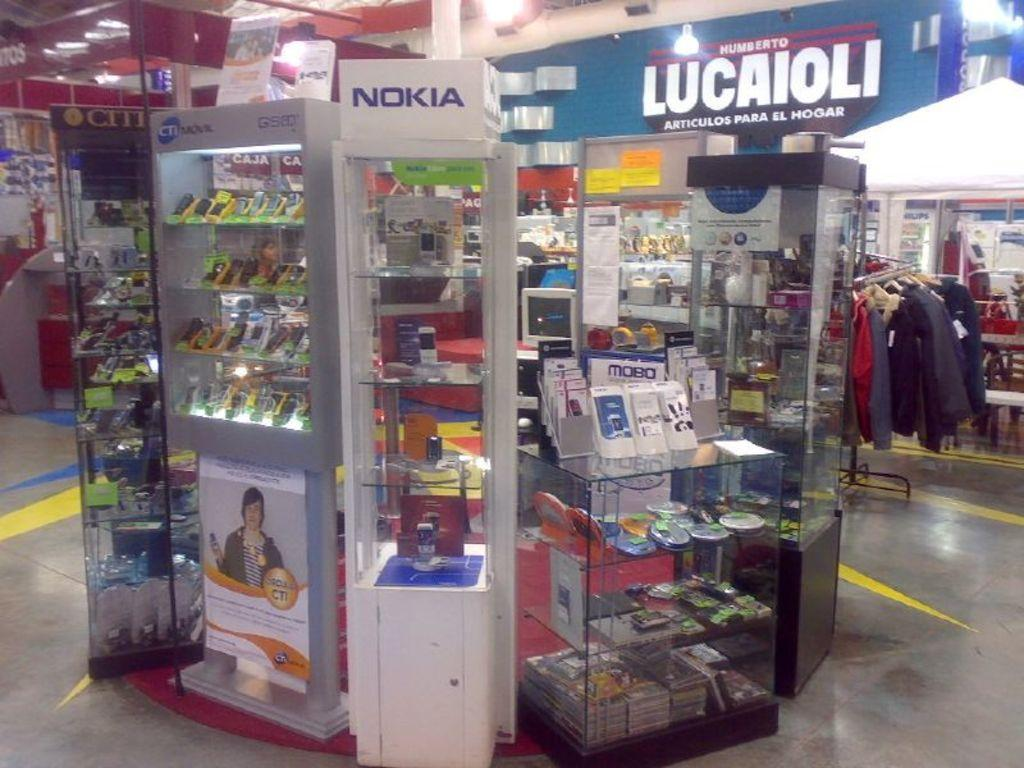<image>
Write a terse but informative summary of the picture. A display for Nokia phones in front of a sign stating Lucaioli 